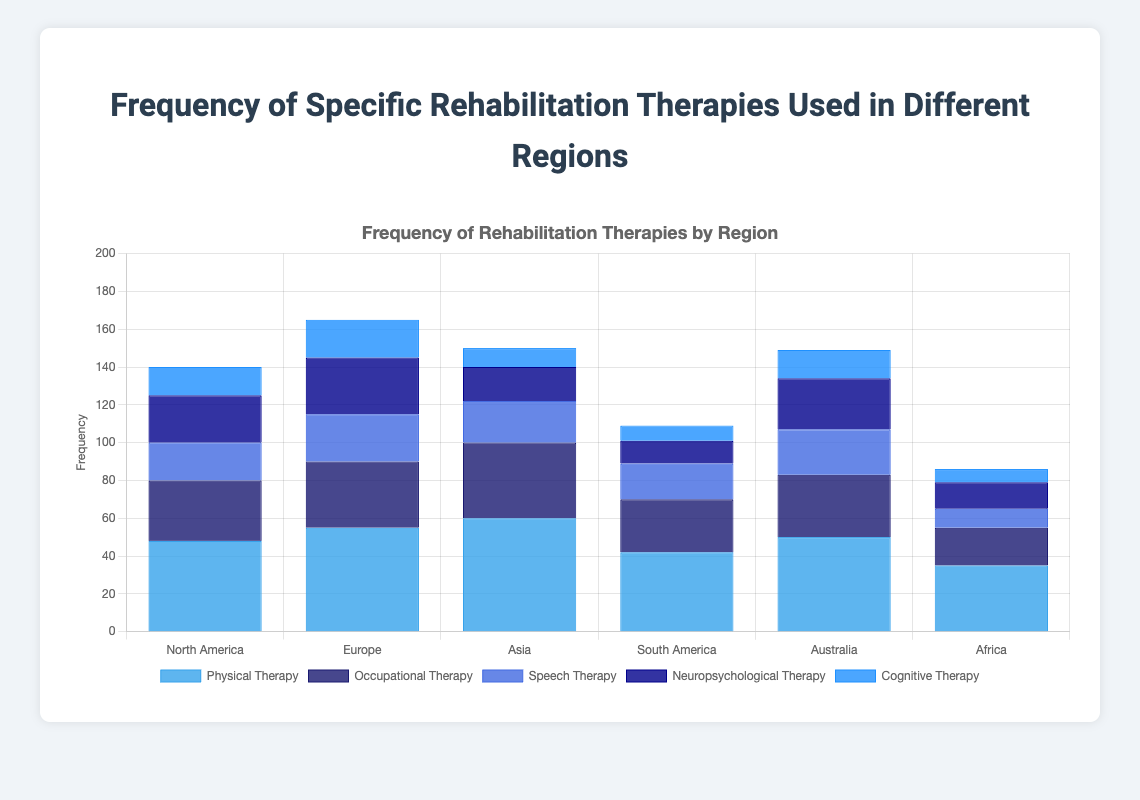Which region has the highest frequency of physical therapy? From the bar chart, observe that the bar representing physical therapy is highest for Asia.
Answer: Asia Which region has the lowest frequency of cognitive therapy? Looking at the bar representing cognitive therapy, the shortest bar is for Africa.
Answer: Africa What is the total frequency of neuropsychological therapy across all regions? Summing the values of neuropsychological therapy for all regions: 25 (North America) + 30 (Europe) + 18 (Asia) + 12 (South America) + 27 (Australia) + 14 (Africa) = 126.
Answer: 126 Compare the frequency of occupational therapy in North America and Europe. Which region has a higher value? North America has a frequency of 32 and Europe has a frequency of 35 for occupational therapy. Europe has a higher value.
Answer: Europe What is the average frequency of speech therapy across all regions? Sum the frequencies of speech therapy for all regions: 20 (North America) + 25 (Europe) + 22 (Asia) + 19 (South America) + 24 (Australia) + 10 (Africa) = 120. The average is 120 / 6 = 20.
Answer: 20 How much greater is the frequency of physical therapy in Asia compared to Africa? The frequency of physical therapy in Asia is 60 and in Africa, it is 35. The difference is 60 - 35 = 25.
Answer: 25 Which therapy has the most balanced frequency across all regions? By observing the variability of the heights of bars for each therapy, it seems that physical therapy shows the least variability across regions.
Answer: Physical therapy 